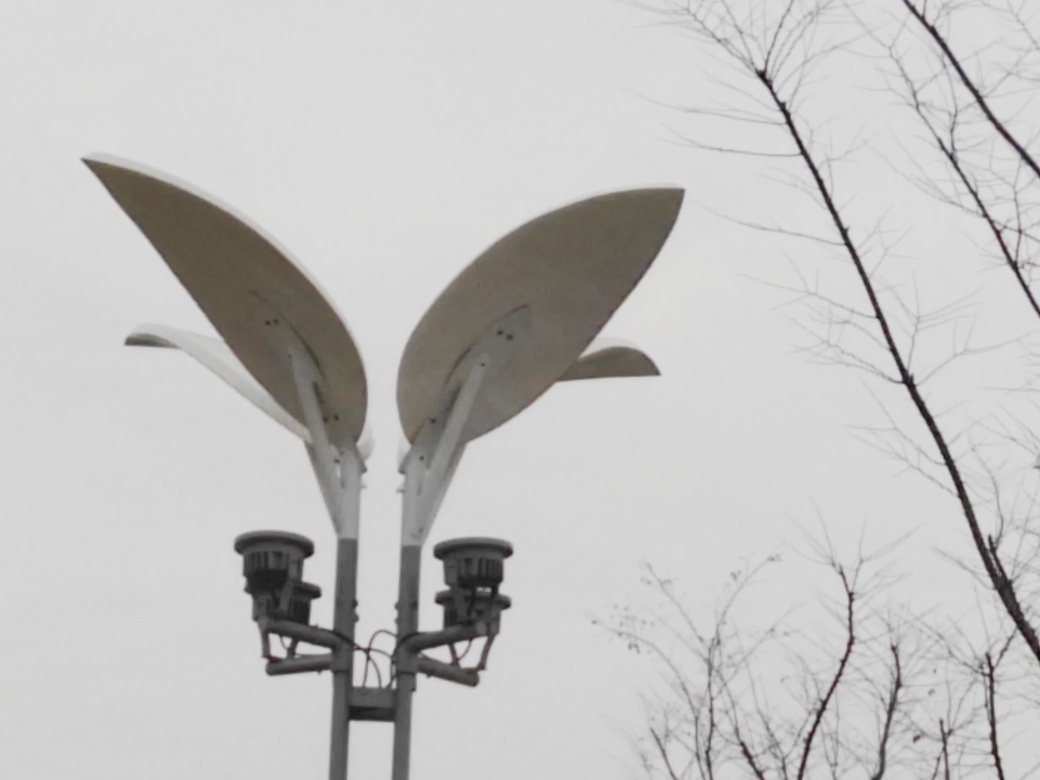How would you characterize the overall colors in this image?
A. Vibrant
B. Colorful
C. Gray
D. Bright
Answer with the option's letter from the given choices directly.
 C. 